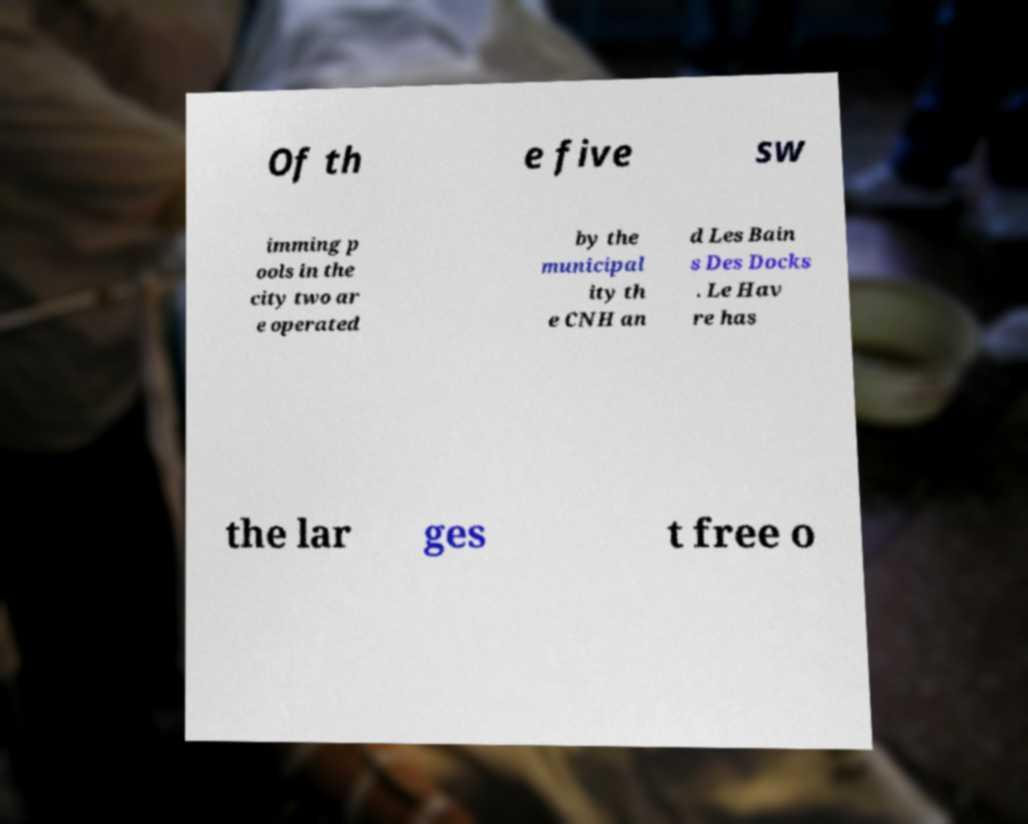Could you extract and type out the text from this image? Of th e five sw imming p ools in the city two ar e operated by the municipal ity th e CNH an d Les Bain s Des Docks . Le Hav re has the lar ges t free o 